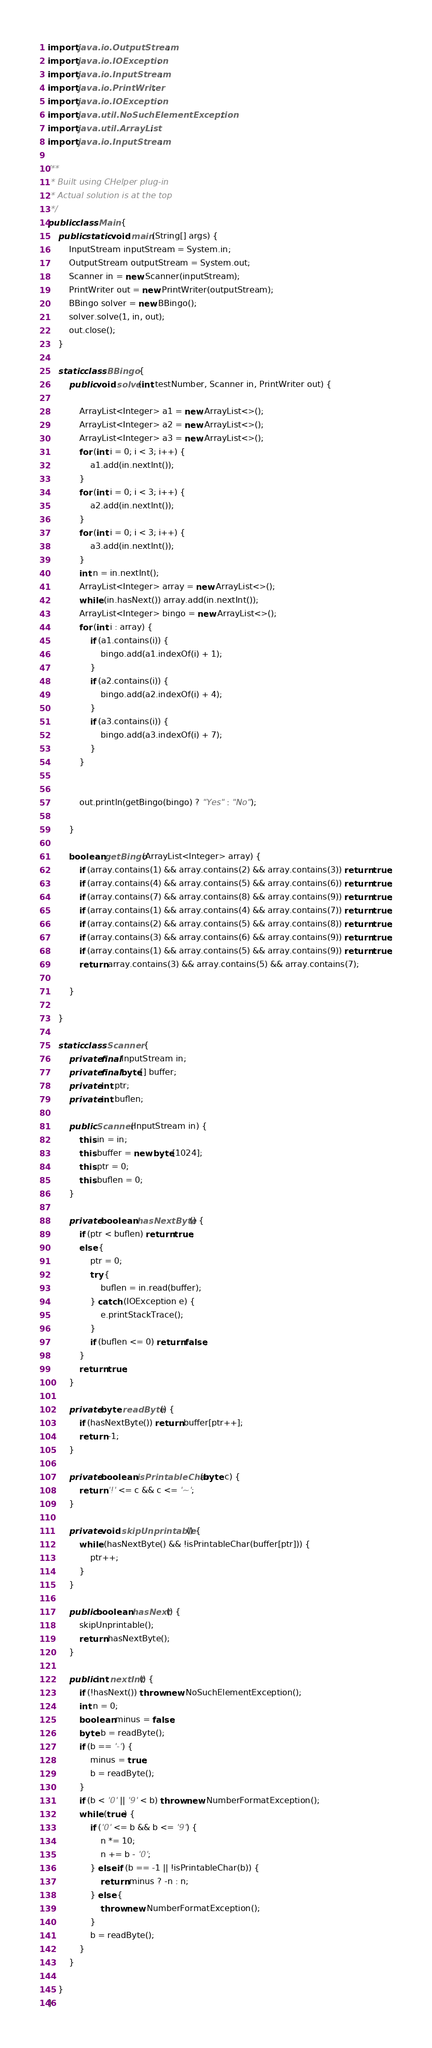<code> <loc_0><loc_0><loc_500><loc_500><_Java_>import java.io.OutputStream;
import java.io.IOException;
import java.io.InputStream;
import java.io.PrintWriter;
import java.io.IOException;
import java.util.NoSuchElementException;
import java.util.ArrayList;
import java.io.InputStream;

/**
 * Built using CHelper plug-in
 * Actual solution is at the top
 */
public class Main {
    public static void main(String[] args) {
        InputStream inputStream = System.in;
        OutputStream outputStream = System.out;
        Scanner in = new Scanner(inputStream);
        PrintWriter out = new PrintWriter(outputStream);
        BBingo solver = new BBingo();
        solver.solve(1, in, out);
        out.close();
    }

    static class BBingo {
        public void solve(int testNumber, Scanner in, PrintWriter out) {

            ArrayList<Integer> a1 = new ArrayList<>();
            ArrayList<Integer> a2 = new ArrayList<>();
            ArrayList<Integer> a3 = new ArrayList<>();
            for (int i = 0; i < 3; i++) {
                a1.add(in.nextInt());
            }
            for (int i = 0; i < 3; i++) {
                a2.add(in.nextInt());
            }
            for (int i = 0; i < 3; i++) {
                a3.add(in.nextInt());
            }
            int n = in.nextInt();
            ArrayList<Integer> array = new ArrayList<>();
            while (in.hasNext()) array.add(in.nextInt());
            ArrayList<Integer> bingo = new ArrayList<>();
            for (int i : array) {
                if (a1.contains(i)) {
                    bingo.add(a1.indexOf(i) + 1);
                }
                if (a2.contains(i)) {
                    bingo.add(a2.indexOf(i) + 4);
                }
                if (a3.contains(i)) {
                    bingo.add(a3.indexOf(i) + 7);
                }
            }


            out.println(getBingo(bingo) ? "Yes" : "No");

        }

        boolean getBingo(ArrayList<Integer> array) {
            if (array.contains(1) && array.contains(2) && array.contains(3)) return true;
            if (array.contains(4) && array.contains(5) && array.contains(6)) return true;
            if (array.contains(7) && array.contains(8) && array.contains(9)) return true;
            if (array.contains(1) && array.contains(4) && array.contains(7)) return true;
            if (array.contains(2) && array.contains(5) && array.contains(8)) return true;
            if (array.contains(3) && array.contains(6) && array.contains(9)) return true;
            if (array.contains(1) && array.contains(5) && array.contains(9)) return true;
            return array.contains(3) && array.contains(5) && array.contains(7);

        }

    }

    static class Scanner {
        private final InputStream in;
        private final byte[] buffer;
        private int ptr;
        private int buflen;

        public Scanner(InputStream in) {
            this.in = in;
            this.buffer = new byte[1024];
            this.ptr = 0;
            this.buflen = 0;
        }

        private boolean hasNextByte() {
            if (ptr < buflen) return true;
            else {
                ptr = 0;
                try {
                    buflen = in.read(buffer);
                } catch (IOException e) {
                    e.printStackTrace();
                }
                if (buflen <= 0) return false;
            }
            return true;
        }

        private byte readByte() {
            if (hasNextByte()) return buffer[ptr++];
            return -1;
        }

        private boolean isPrintableChar(byte c) {
            return '!' <= c && c <= '~';
        }

        private void skipUnprintable() {
            while (hasNextByte() && !isPrintableChar(buffer[ptr])) {
                ptr++;
            }
        }

        public boolean hasNext() {
            skipUnprintable();
            return hasNextByte();
        }

        public int nextInt() {
            if (!hasNext()) throw new NoSuchElementException();
            int n = 0;
            boolean minus = false;
            byte b = readByte();
            if (b == '-') {
                minus = true;
                b = readByte();
            }
            if (b < '0' || '9' < b) throw new NumberFormatException();
            while (true) {
                if ('0' <= b && b <= '9') {
                    n *= 10;
                    n += b - '0';
                } else if (b == -1 || !isPrintableChar(b)) {
                    return minus ? -n : n;
                } else {
                    throw new NumberFormatException();
                }
                b = readByte();
            }
        }

    }
}

</code> 